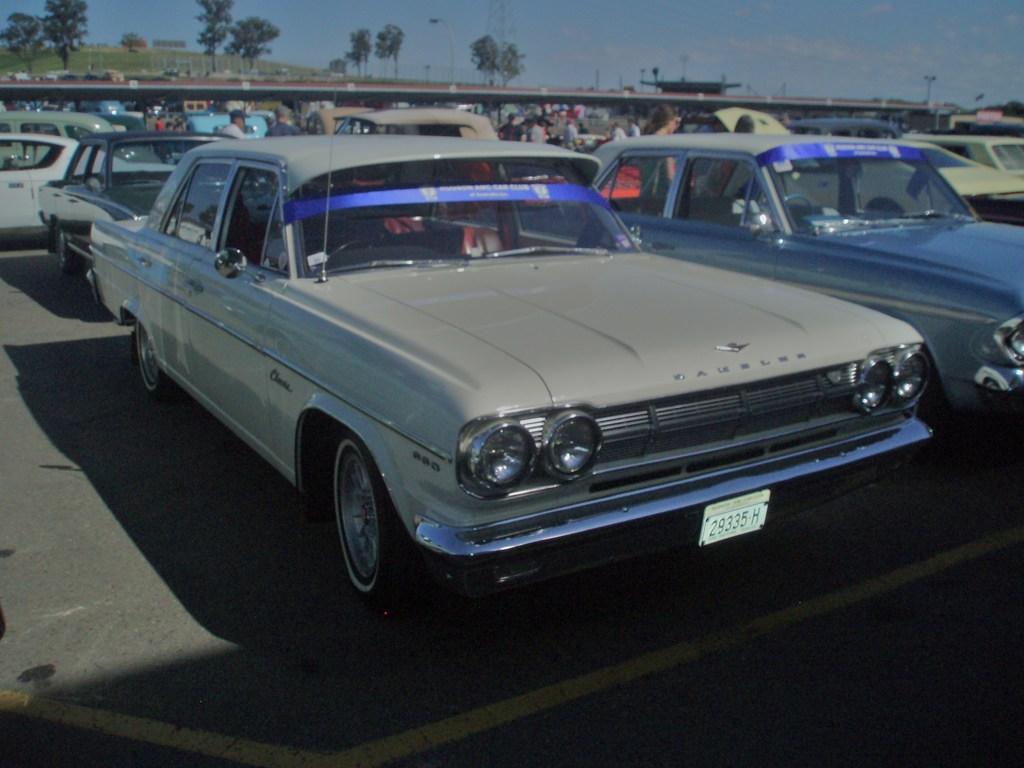Describe this image in one or two sentences. In this image, we can see so many vehicles are parked on the road. Background we can see few people and trees. Top of the image, there is a sky. 